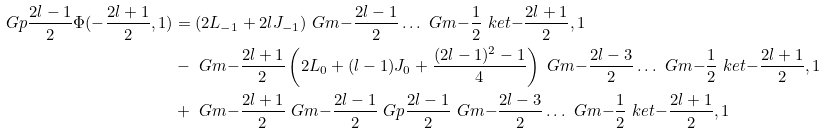Convert formula to latex. <formula><loc_0><loc_0><loc_500><loc_500>\ G p { \frac { 2 l - 1 } { 2 } } \Phi ( - \frac { 2 l + 1 } { 2 } , 1 ) & = ( 2 L _ { - 1 } + 2 l J _ { - 1 } ) \ G m { - \frac { 2 l - 1 } { 2 } } \dots \ G m { - \frac { 1 } { 2 } } \ k e t { - \frac { 2 l + 1 } { 2 } , 1 } \\ & - \ G m { - \frac { 2 l + 1 } { 2 } } \left ( 2 L _ { 0 } + ( l - 1 ) J _ { 0 } + \frac { ( 2 l - 1 ) ^ { 2 } - 1 } { 4 } \right ) \ G m { - \frac { 2 l - 3 } { 2 } } \dots \ G m { - \frac { 1 } { 2 } } \ k e t { - \frac { 2 l + 1 } { 2 } , 1 } \\ & + \ G m { - \frac { 2 l + 1 } { 2 } } \ G m { - \frac { 2 l - 1 } { 2 } } \ G p { \frac { 2 l - 1 } { 2 } } \ G m { - \frac { 2 l - 3 } { 2 } } \dots \ G m { - \frac { 1 } { 2 } } \ k e t { - \frac { 2 l + 1 } { 2 } , 1 }</formula> 